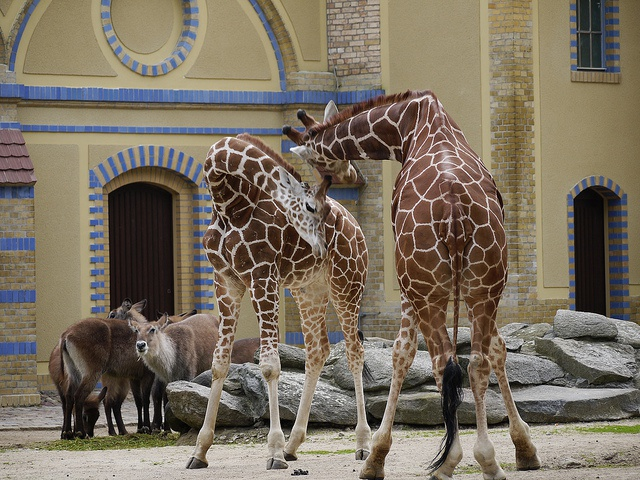Describe the objects in this image and their specific colors. I can see giraffe in gray, maroon, and black tones and giraffe in gray, darkgray, maroon, and black tones in this image. 